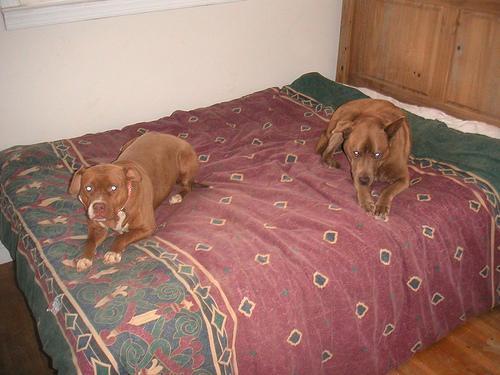How many dogs are there?
Give a very brief answer. 2. How many people are holding tennis balls in the picture?
Give a very brief answer. 0. 